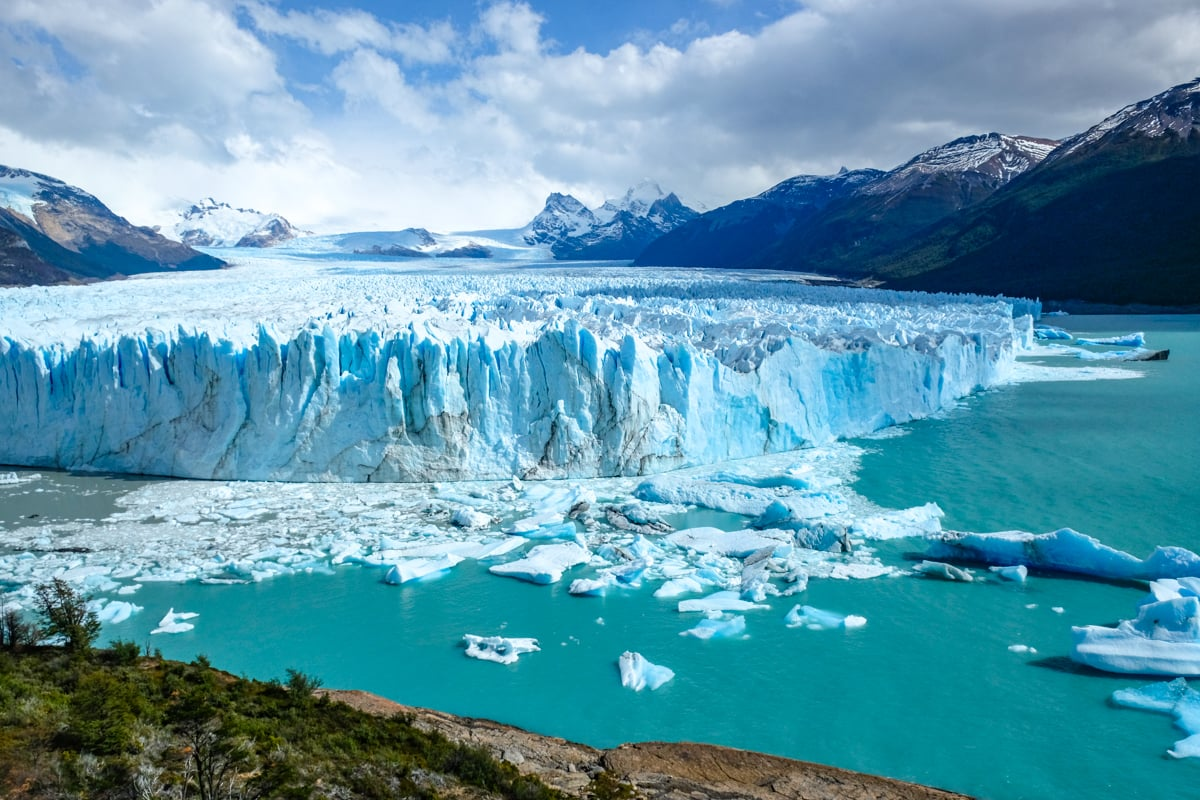Can you tell me more about how glaciers like the Perito Moreno contribute to global ecosystems? Glaciers like the Perito Moreno play a vital role in global ecosystems. As immense reservoirs of freshwater, they store about 75% of the world's fresh water. In addition to providing water for human use, agriculture, and hydroelectric energy, glaciers help to regulate the earth's temperature. Their bright surfaces reflect sunlight, which helps to moderate global climate. However, with climate change causing accelerated melting, glaciers are also significant indicators of environmental shifts, impacting sea levels and freshwater availability worldwide. 